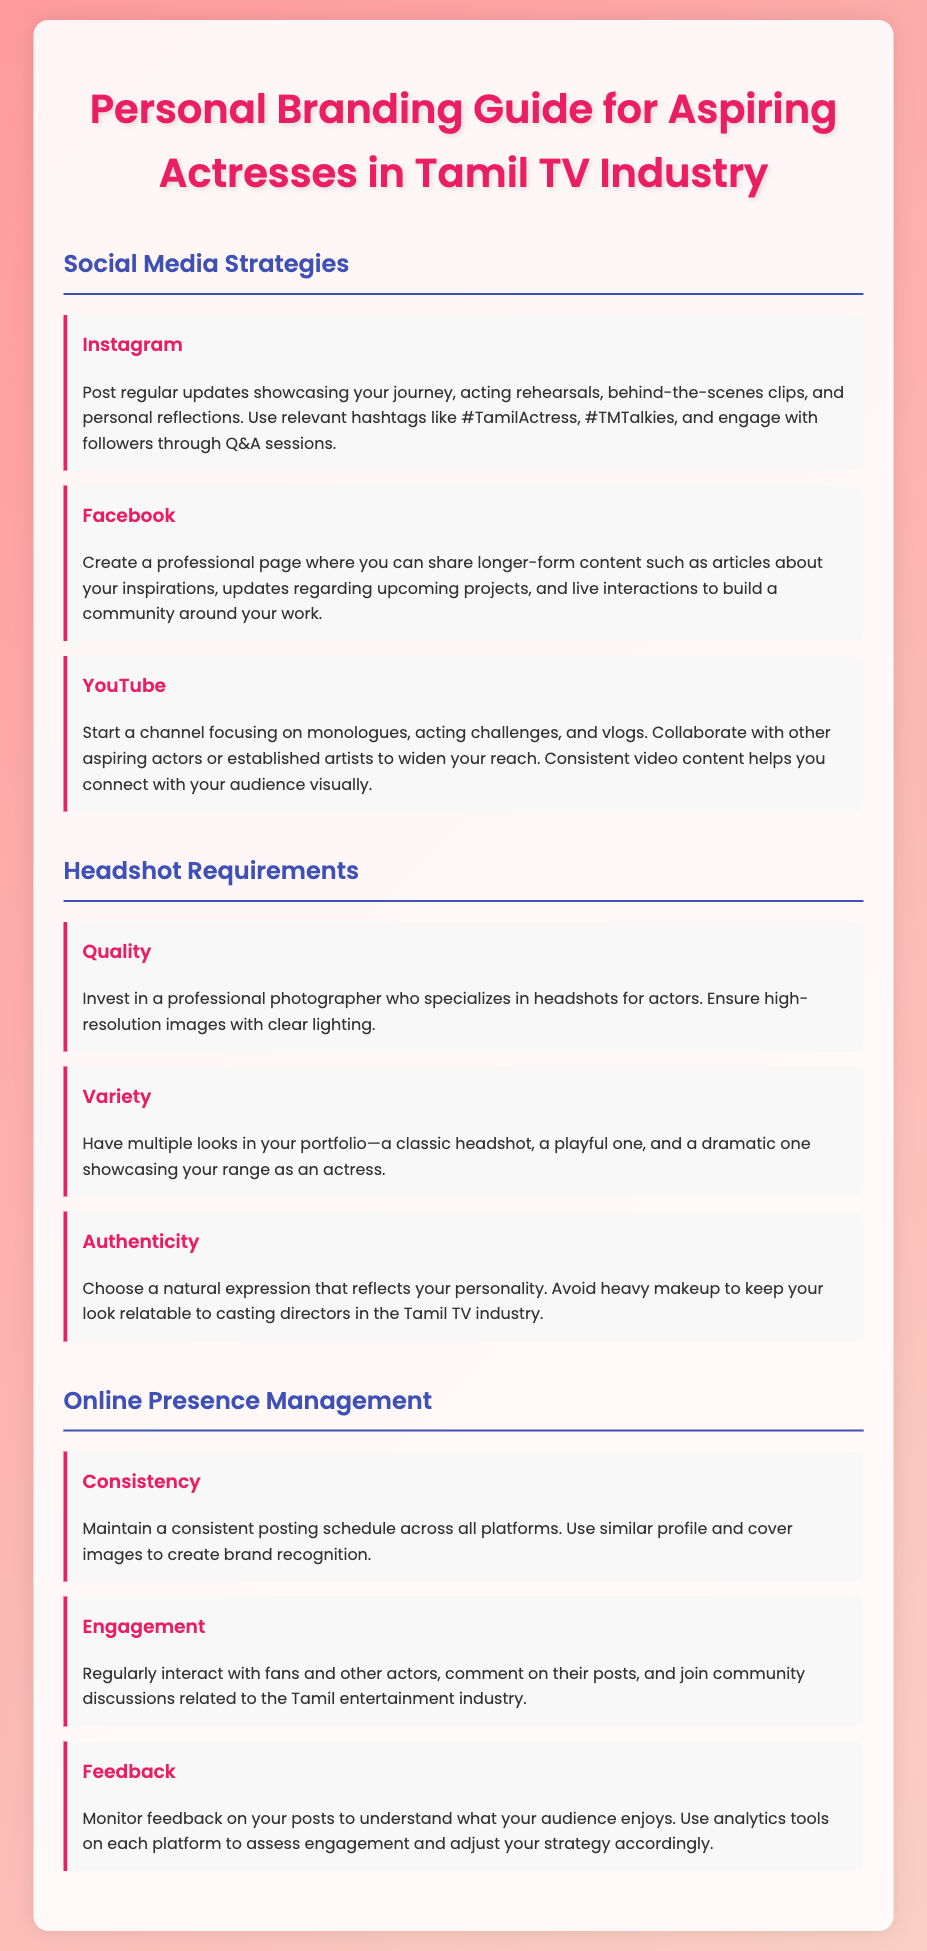What are the recommended social media platforms? The document lists Instagram, Facebook, and YouTube as recommended social media platforms for aspiring actresses.
Answer: Instagram, Facebook, YouTube What is one suggested strategy for Instagram? The document suggests posting regular updates showcasing your journey, acting rehearsals, and behind-the-scenes clips.
Answer: Post regular updates What type of content should be shared on Facebook? It mentions that longer-form content such as articles about inspirations and updates regarding projects should be shared.
Answer: Longer-form content What is the recommended quality for headshots? The document advises investing in a professional photographer who provides high-resolution images with clear lighting.
Answer: High-resolution images How many different looks should be in a headshot portfolio? The document states that having multiple looks is essential, such as a classic headshot, playful, and dramatic one.
Answer: Multiple looks What is a key aspect of online presence management? Consistency in posting schedules across all platforms and using similar images for brand recognition is emphasized.
Answer: Consistency What is one way to engage with followers? The document mentions regularly interacting with fans and commenting on their posts.
Answer: Interact with fans What type of feedback should be monitored? It points out that feedback on posts should be monitored to understand audience preferences.
Answer: Audience preferences What is one example of content for a YouTube channel? The guide suggests starting a channel with monologues, acting challenges, and vlogs as content examples.
Answer: Monologues, acting challenges, vlogs 